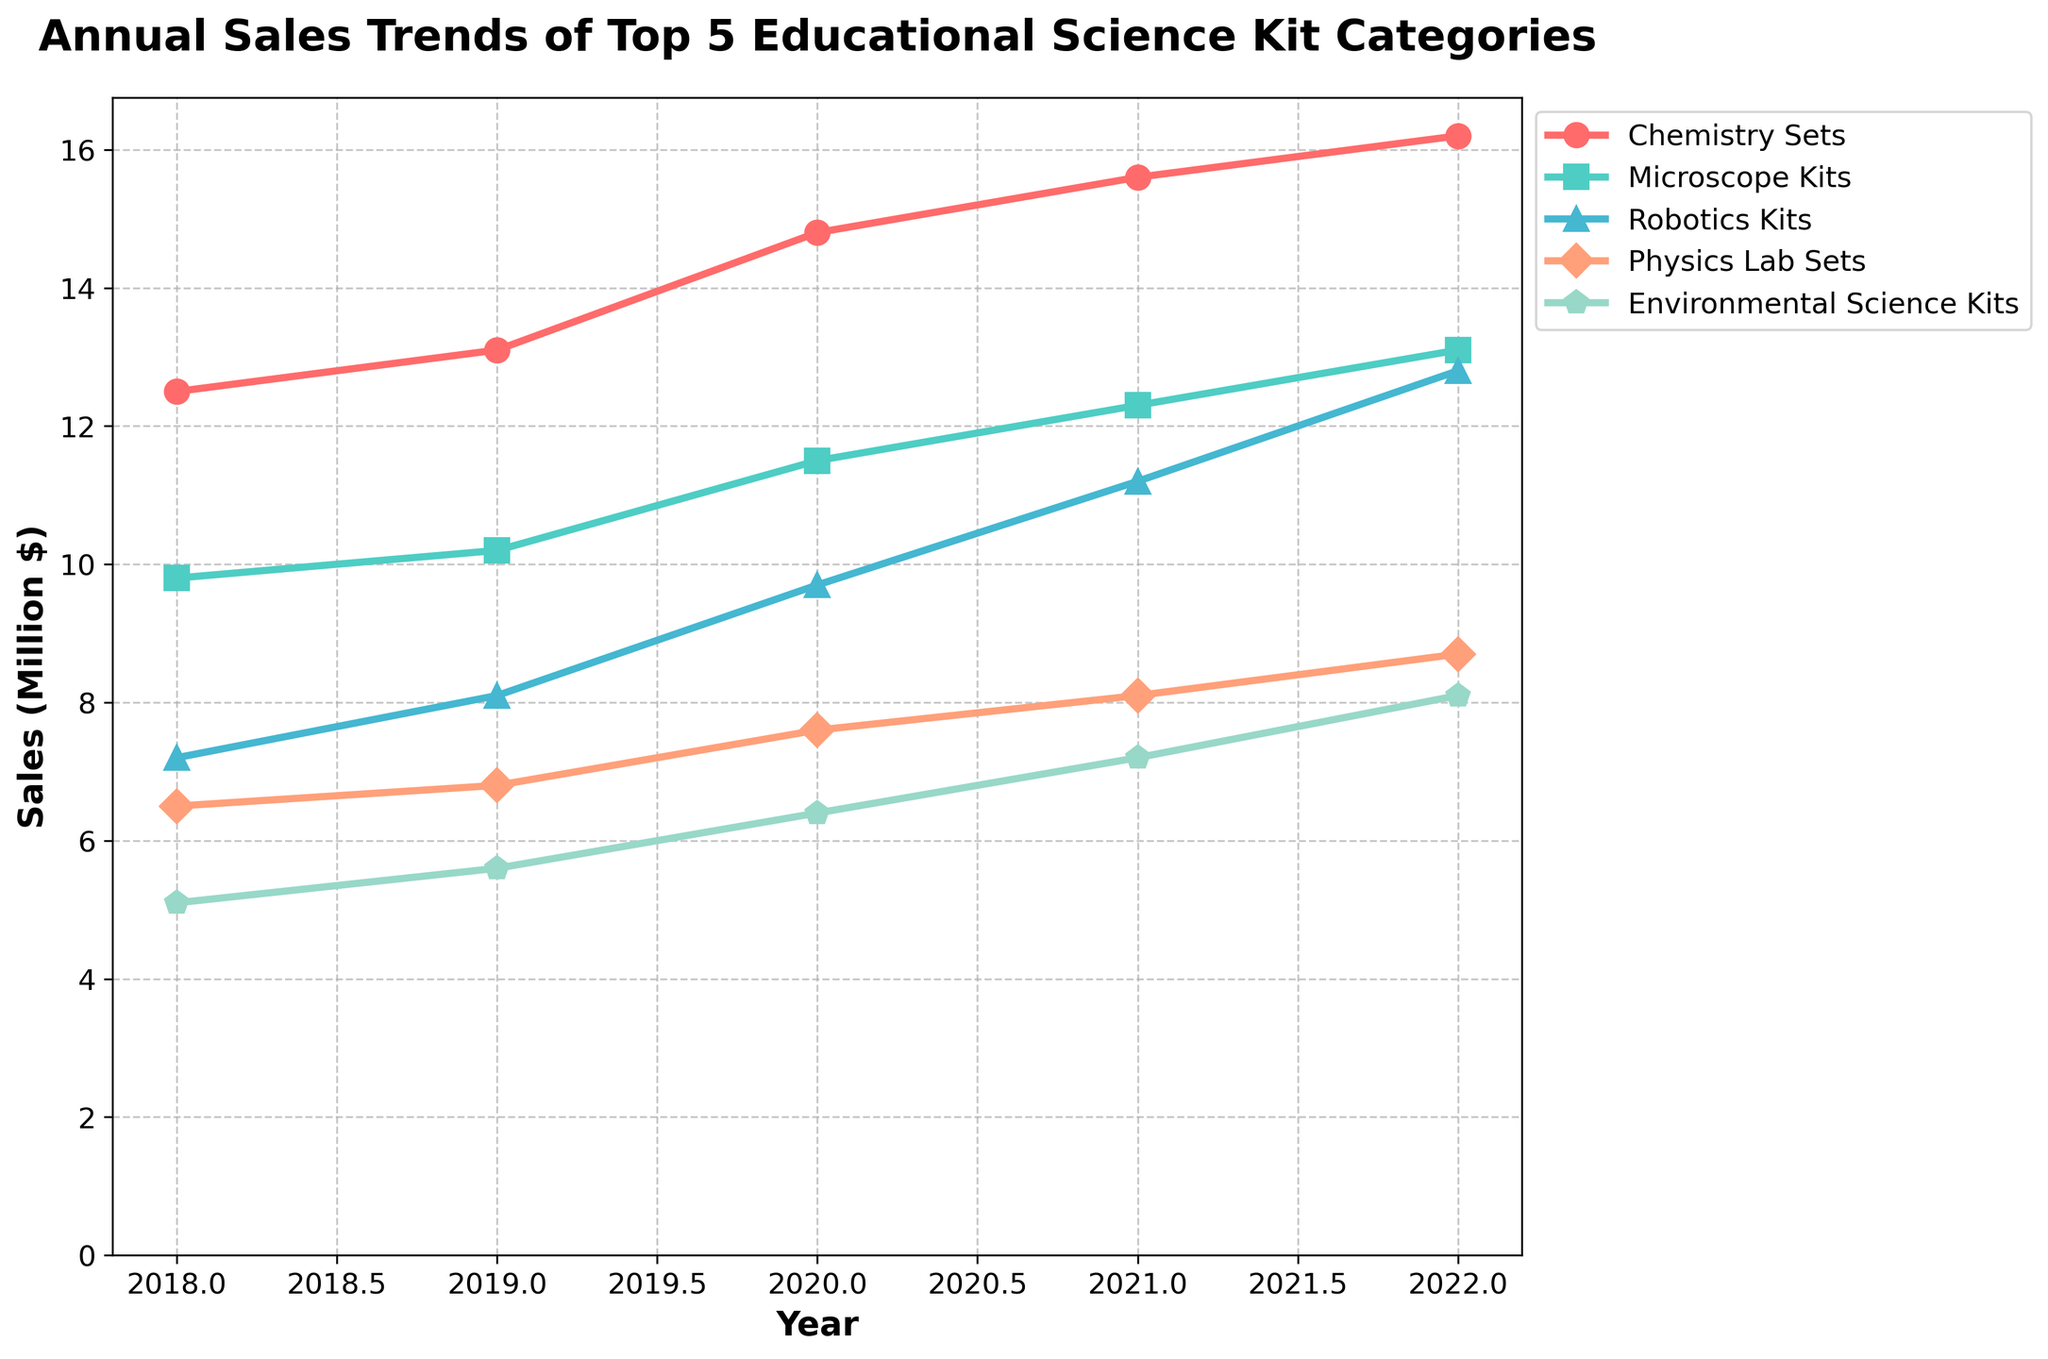Which category had the highest sales in 2022? Look at the line for each category at the point corresponding to 2022 and compare the heights. Chemistry Sets has the highest sales.
Answer: Chemistry Sets Which category saw the largest increase in sales between 2018 and 2022? Calculate the difference in sales for each category between 2018 and 2022, then compare. Chemistry Sets had the largest increase (16.2M - 12.5M = 3.7M).
Answer: Chemistry Sets In which year did Robotics Kits sales surpass Physics Lab Sets? Identify the years where the line for Robotics Kits is higher than the line for Physics Lab Sets. The first such year is 2021.
Answer: 2021 What's the average sales of Environmental Science Kits over the years? Sum the sales figures for Environmental Science Kits from 2018 to 2022 and then divide by the number of years. (5.1M + 5.6M + 6.4M + 7.2M + 8.1M) / 5 = 6.48M.
Answer: 6.48 Million $ Which category had the smallest sales in 2020? Look at the line for each category at the point corresponding to 2020 and identify the lowest one. Environmental Science Kits had the smallest sales.
Answer: Environmental Science Kits By how much did the sales of Chemistry Sets increase from 2019 to 2020? Calculate the difference between sales figures of Chemistry Sets for 2020 and 2019. 14.8M - 13.1M = 1.7M.
Answer: 1.7 Million $ Which two categories had the closest sales in 2021? Compare the sales figures for all categories in 2021 and find the two closest values. Physics Lab Sets and Environmental Science Kits had sales of 8.1M and 7.2M, respectively.
Answer: Physics Lab Sets and Environmental Science Kits From 2018 to 2022, which category showed a steady increase every year? Examine the trend for each category and determine which one shows consistent year-on-year growth. Chemistry Sets show a steady increase each year.
Answer: Chemistry Sets What's the total combined sales of all categories in 2020? Sum the sales figures of all five categories for the year 2020. 14.8M + 11.5M + 9.7M + 7.6M + 6.4M = 50M.
Answer: 50 Million $ Which category's sales doubled from 2018 to 2022? Compare the sales figures of each category between 2018 and 2022 and see if there was a two-fold increase. Robotics Kits' sales went from 7.2M to 12.8M, which is more than double.
Answer: Robotics Kits 